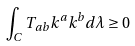Convert formula to latex. <formula><loc_0><loc_0><loc_500><loc_500>\int _ { C } T _ { a b } k ^ { a } k ^ { b } d \lambda \geq 0</formula> 